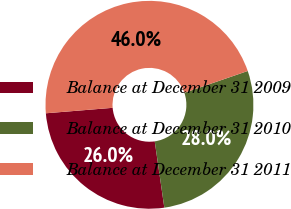<chart> <loc_0><loc_0><loc_500><loc_500><pie_chart><fcel>Balance at December 31 2009<fcel>Balance at December 31 2010<fcel>Balance at December 31 2011<nl><fcel>25.99%<fcel>27.99%<fcel>46.03%<nl></chart> 